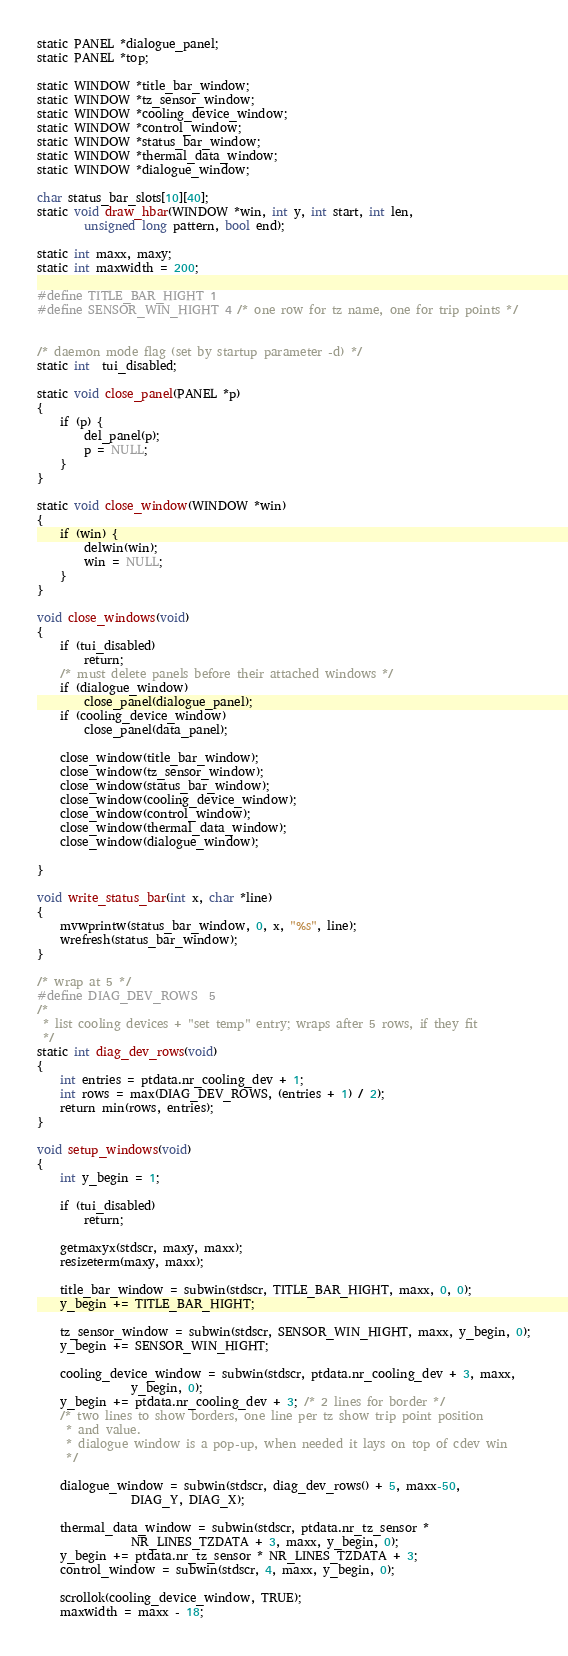<code> <loc_0><loc_0><loc_500><loc_500><_C_>static PANEL *dialogue_panel;
static PANEL *top;

static WINDOW *title_bar_window;
static WINDOW *tz_sensor_window;
static WINDOW *cooling_device_window;
static WINDOW *control_window;
static WINDOW *status_bar_window;
static WINDOW *thermal_data_window;
static WINDOW *dialogue_window;

char status_bar_slots[10][40];
static void draw_hbar(WINDOW *win, int y, int start, int len,
		unsigned long pattern, bool end);

static int maxx, maxy;
static int maxwidth = 200;

#define TITLE_BAR_HIGHT 1
#define SENSOR_WIN_HIGHT 4 /* one row for tz name, one for trip points */


/* daemon mode flag (set by startup parameter -d) */
static int  tui_disabled;

static void close_panel(PANEL *p)
{
	if (p) {
		del_panel(p);
		p = NULL;
	}
}

static void close_window(WINDOW *win)
{
	if (win) {
		delwin(win);
		win = NULL;
	}
}

void close_windows(void)
{
	if (tui_disabled)
		return;
	/* must delete panels before their attached windows */
	if (dialogue_window)
		close_panel(dialogue_panel);
	if (cooling_device_window)
		close_panel(data_panel);

	close_window(title_bar_window);
	close_window(tz_sensor_window);
	close_window(status_bar_window);
	close_window(cooling_device_window);
	close_window(control_window);
	close_window(thermal_data_window);
	close_window(dialogue_window);

}

void write_status_bar(int x, char *line)
{
	mvwprintw(status_bar_window, 0, x, "%s", line);
	wrefresh(status_bar_window);
}

/* wrap at 5 */
#define DIAG_DEV_ROWS  5
/*
 * list cooling devices + "set temp" entry; wraps after 5 rows, if they fit
 */
static int diag_dev_rows(void)
{
	int entries = ptdata.nr_cooling_dev + 1;
	int rows = max(DIAG_DEV_ROWS, (entries + 1) / 2);
	return min(rows, entries);
}

void setup_windows(void)
{
	int y_begin = 1;

	if (tui_disabled)
		return;

	getmaxyx(stdscr, maxy, maxx);
	resizeterm(maxy, maxx);

	title_bar_window = subwin(stdscr, TITLE_BAR_HIGHT, maxx, 0, 0);
	y_begin += TITLE_BAR_HIGHT;

	tz_sensor_window = subwin(stdscr, SENSOR_WIN_HIGHT, maxx, y_begin, 0);
	y_begin += SENSOR_WIN_HIGHT;

	cooling_device_window = subwin(stdscr, ptdata.nr_cooling_dev + 3, maxx,
				y_begin, 0);
	y_begin += ptdata.nr_cooling_dev + 3; /* 2 lines for border */
	/* two lines to show borders, one line per tz show trip point position
	 * and value.
	 * dialogue window is a pop-up, when needed it lays on top of cdev win
	 */

	dialogue_window = subwin(stdscr, diag_dev_rows() + 5, maxx-50,
				DIAG_Y, DIAG_X);

	thermal_data_window = subwin(stdscr, ptdata.nr_tz_sensor *
				NR_LINES_TZDATA + 3, maxx, y_begin, 0);
	y_begin += ptdata.nr_tz_sensor * NR_LINES_TZDATA + 3;
	control_window = subwin(stdscr, 4, maxx, y_begin, 0);

	scrollok(cooling_device_window, TRUE);
	maxwidth = maxx - 18;</code> 